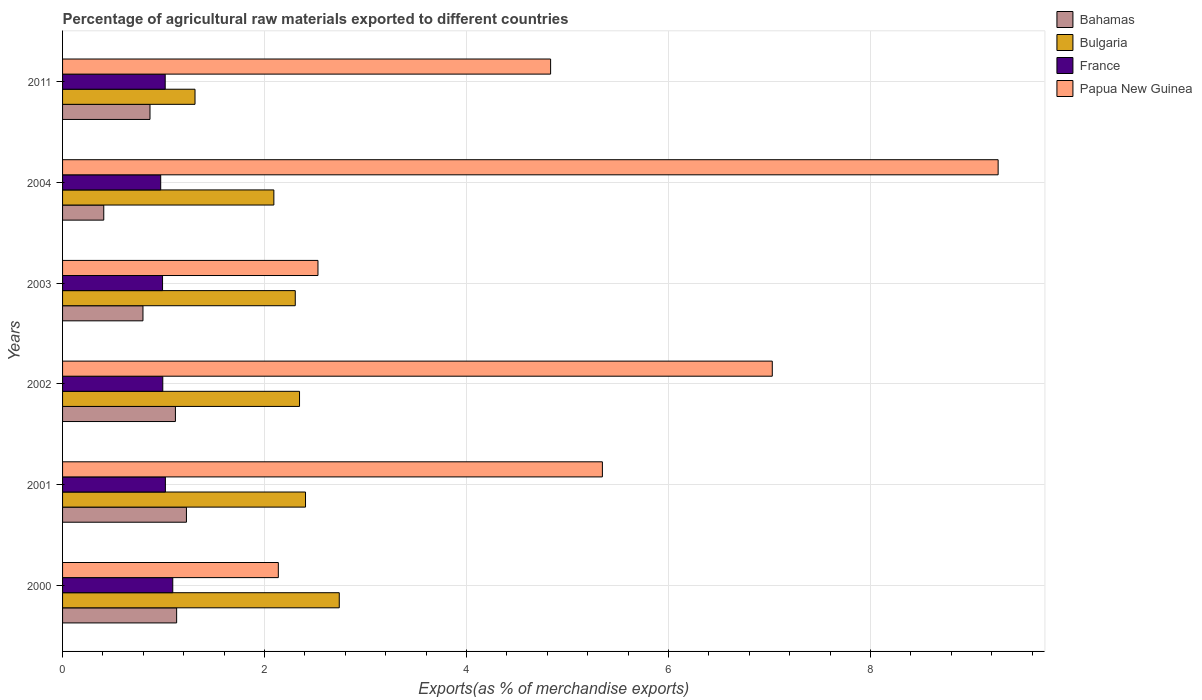How many different coloured bars are there?
Offer a terse response. 4. How many groups of bars are there?
Ensure brevity in your answer.  6. How many bars are there on the 3rd tick from the top?
Provide a succinct answer. 4. What is the label of the 5th group of bars from the top?
Offer a very short reply. 2001. What is the percentage of exports to different countries in France in 2011?
Offer a very short reply. 1.02. Across all years, what is the maximum percentage of exports to different countries in Bulgaria?
Provide a succinct answer. 2.74. Across all years, what is the minimum percentage of exports to different countries in France?
Your response must be concise. 0.97. What is the total percentage of exports to different countries in Papua New Guinea in the graph?
Ensure brevity in your answer.  31.13. What is the difference between the percentage of exports to different countries in France in 2001 and that in 2002?
Make the answer very short. 0.03. What is the difference between the percentage of exports to different countries in Bulgaria in 2001 and the percentage of exports to different countries in Papua New Guinea in 2002?
Give a very brief answer. -4.62. What is the average percentage of exports to different countries in Bahamas per year?
Keep it short and to the point. 0.92. In the year 2004, what is the difference between the percentage of exports to different countries in France and percentage of exports to different countries in Papua New Guinea?
Your response must be concise. -8.29. What is the ratio of the percentage of exports to different countries in Bulgaria in 2001 to that in 2011?
Give a very brief answer. 1.83. What is the difference between the highest and the second highest percentage of exports to different countries in France?
Give a very brief answer. 0.07. What is the difference between the highest and the lowest percentage of exports to different countries in France?
Give a very brief answer. 0.12. Is the sum of the percentage of exports to different countries in Bahamas in 2003 and 2004 greater than the maximum percentage of exports to different countries in Papua New Guinea across all years?
Provide a short and direct response. No. What does the 4th bar from the top in 2000 represents?
Your answer should be very brief. Bahamas. Is it the case that in every year, the sum of the percentage of exports to different countries in France and percentage of exports to different countries in Bulgaria is greater than the percentage of exports to different countries in Papua New Guinea?
Offer a terse response. No. How many bars are there?
Offer a very short reply. 24. What is the difference between two consecutive major ticks on the X-axis?
Your response must be concise. 2. Are the values on the major ticks of X-axis written in scientific E-notation?
Your answer should be very brief. No. Does the graph contain any zero values?
Offer a terse response. No. Does the graph contain grids?
Your answer should be compact. Yes. Where does the legend appear in the graph?
Your answer should be very brief. Top right. What is the title of the graph?
Make the answer very short. Percentage of agricultural raw materials exported to different countries. What is the label or title of the X-axis?
Make the answer very short. Exports(as % of merchandise exports). What is the Exports(as % of merchandise exports) of Bahamas in 2000?
Your answer should be compact. 1.13. What is the Exports(as % of merchandise exports) of Bulgaria in 2000?
Your answer should be compact. 2.74. What is the Exports(as % of merchandise exports) in France in 2000?
Your answer should be compact. 1.09. What is the Exports(as % of merchandise exports) in Papua New Guinea in 2000?
Make the answer very short. 2.14. What is the Exports(as % of merchandise exports) of Bahamas in 2001?
Offer a terse response. 1.23. What is the Exports(as % of merchandise exports) of Bulgaria in 2001?
Provide a succinct answer. 2.41. What is the Exports(as % of merchandise exports) of France in 2001?
Your answer should be very brief. 1.02. What is the Exports(as % of merchandise exports) in Papua New Guinea in 2001?
Your answer should be compact. 5.34. What is the Exports(as % of merchandise exports) in Bahamas in 2002?
Keep it short and to the point. 1.12. What is the Exports(as % of merchandise exports) of Bulgaria in 2002?
Your answer should be very brief. 2.35. What is the Exports(as % of merchandise exports) in France in 2002?
Give a very brief answer. 0.99. What is the Exports(as % of merchandise exports) of Papua New Guinea in 2002?
Give a very brief answer. 7.03. What is the Exports(as % of merchandise exports) in Bahamas in 2003?
Ensure brevity in your answer.  0.8. What is the Exports(as % of merchandise exports) of Bulgaria in 2003?
Keep it short and to the point. 2.3. What is the Exports(as % of merchandise exports) in France in 2003?
Make the answer very short. 0.99. What is the Exports(as % of merchandise exports) of Papua New Guinea in 2003?
Ensure brevity in your answer.  2.53. What is the Exports(as % of merchandise exports) of Bahamas in 2004?
Make the answer very short. 0.41. What is the Exports(as % of merchandise exports) of Bulgaria in 2004?
Offer a very short reply. 2.09. What is the Exports(as % of merchandise exports) of France in 2004?
Your response must be concise. 0.97. What is the Exports(as % of merchandise exports) in Papua New Guinea in 2004?
Your answer should be compact. 9.26. What is the Exports(as % of merchandise exports) of Bahamas in 2011?
Your response must be concise. 0.87. What is the Exports(as % of merchandise exports) of Bulgaria in 2011?
Give a very brief answer. 1.31. What is the Exports(as % of merchandise exports) in France in 2011?
Offer a very short reply. 1.02. What is the Exports(as % of merchandise exports) of Papua New Guinea in 2011?
Offer a very short reply. 4.83. Across all years, what is the maximum Exports(as % of merchandise exports) in Bahamas?
Keep it short and to the point. 1.23. Across all years, what is the maximum Exports(as % of merchandise exports) in Bulgaria?
Make the answer very short. 2.74. Across all years, what is the maximum Exports(as % of merchandise exports) in France?
Provide a short and direct response. 1.09. Across all years, what is the maximum Exports(as % of merchandise exports) in Papua New Guinea?
Your answer should be compact. 9.26. Across all years, what is the minimum Exports(as % of merchandise exports) in Bahamas?
Provide a succinct answer. 0.41. Across all years, what is the minimum Exports(as % of merchandise exports) in Bulgaria?
Keep it short and to the point. 1.31. Across all years, what is the minimum Exports(as % of merchandise exports) in France?
Ensure brevity in your answer.  0.97. Across all years, what is the minimum Exports(as % of merchandise exports) of Papua New Guinea?
Offer a very short reply. 2.14. What is the total Exports(as % of merchandise exports) of Bahamas in the graph?
Your answer should be compact. 5.54. What is the total Exports(as % of merchandise exports) in Bulgaria in the graph?
Make the answer very short. 13.2. What is the total Exports(as % of merchandise exports) of France in the graph?
Make the answer very short. 6.08. What is the total Exports(as % of merchandise exports) in Papua New Guinea in the graph?
Keep it short and to the point. 31.13. What is the difference between the Exports(as % of merchandise exports) of Bahamas in 2000 and that in 2001?
Keep it short and to the point. -0.1. What is the difference between the Exports(as % of merchandise exports) in Bulgaria in 2000 and that in 2001?
Offer a very short reply. 0.33. What is the difference between the Exports(as % of merchandise exports) of France in 2000 and that in 2001?
Keep it short and to the point. 0.07. What is the difference between the Exports(as % of merchandise exports) in Papua New Guinea in 2000 and that in 2001?
Your response must be concise. -3.21. What is the difference between the Exports(as % of merchandise exports) in Bahamas in 2000 and that in 2002?
Ensure brevity in your answer.  0.01. What is the difference between the Exports(as % of merchandise exports) of Bulgaria in 2000 and that in 2002?
Make the answer very short. 0.39. What is the difference between the Exports(as % of merchandise exports) in France in 2000 and that in 2002?
Offer a terse response. 0.1. What is the difference between the Exports(as % of merchandise exports) in Papua New Guinea in 2000 and that in 2002?
Keep it short and to the point. -4.89. What is the difference between the Exports(as % of merchandise exports) in Bulgaria in 2000 and that in 2003?
Keep it short and to the point. 0.44. What is the difference between the Exports(as % of merchandise exports) of France in 2000 and that in 2003?
Provide a succinct answer. 0.1. What is the difference between the Exports(as % of merchandise exports) in Papua New Guinea in 2000 and that in 2003?
Your response must be concise. -0.39. What is the difference between the Exports(as % of merchandise exports) in Bahamas in 2000 and that in 2004?
Keep it short and to the point. 0.72. What is the difference between the Exports(as % of merchandise exports) of Bulgaria in 2000 and that in 2004?
Offer a very short reply. 0.65. What is the difference between the Exports(as % of merchandise exports) in France in 2000 and that in 2004?
Offer a very short reply. 0.12. What is the difference between the Exports(as % of merchandise exports) of Papua New Guinea in 2000 and that in 2004?
Your answer should be very brief. -7.13. What is the difference between the Exports(as % of merchandise exports) in Bahamas in 2000 and that in 2011?
Ensure brevity in your answer.  0.26. What is the difference between the Exports(as % of merchandise exports) of Bulgaria in 2000 and that in 2011?
Offer a terse response. 1.43. What is the difference between the Exports(as % of merchandise exports) of France in 2000 and that in 2011?
Offer a very short reply. 0.07. What is the difference between the Exports(as % of merchandise exports) of Papua New Guinea in 2000 and that in 2011?
Your response must be concise. -2.7. What is the difference between the Exports(as % of merchandise exports) in Bahamas in 2001 and that in 2002?
Your answer should be very brief. 0.11. What is the difference between the Exports(as % of merchandise exports) in Bulgaria in 2001 and that in 2002?
Your answer should be very brief. 0.06. What is the difference between the Exports(as % of merchandise exports) in France in 2001 and that in 2002?
Your response must be concise. 0.03. What is the difference between the Exports(as % of merchandise exports) in Papua New Guinea in 2001 and that in 2002?
Your answer should be very brief. -1.68. What is the difference between the Exports(as % of merchandise exports) of Bahamas in 2001 and that in 2003?
Give a very brief answer. 0.43. What is the difference between the Exports(as % of merchandise exports) in Bulgaria in 2001 and that in 2003?
Provide a succinct answer. 0.1. What is the difference between the Exports(as % of merchandise exports) in France in 2001 and that in 2003?
Ensure brevity in your answer.  0.03. What is the difference between the Exports(as % of merchandise exports) in Papua New Guinea in 2001 and that in 2003?
Your answer should be very brief. 2.82. What is the difference between the Exports(as % of merchandise exports) in Bahamas in 2001 and that in 2004?
Give a very brief answer. 0.82. What is the difference between the Exports(as % of merchandise exports) in Bulgaria in 2001 and that in 2004?
Your answer should be compact. 0.31. What is the difference between the Exports(as % of merchandise exports) in France in 2001 and that in 2004?
Your response must be concise. 0.05. What is the difference between the Exports(as % of merchandise exports) in Papua New Guinea in 2001 and that in 2004?
Your answer should be very brief. -3.92. What is the difference between the Exports(as % of merchandise exports) in Bahamas in 2001 and that in 2011?
Offer a terse response. 0.36. What is the difference between the Exports(as % of merchandise exports) of Bulgaria in 2001 and that in 2011?
Your response must be concise. 1.09. What is the difference between the Exports(as % of merchandise exports) of France in 2001 and that in 2011?
Your response must be concise. 0. What is the difference between the Exports(as % of merchandise exports) of Papua New Guinea in 2001 and that in 2011?
Make the answer very short. 0.51. What is the difference between the Exports(as % of merchandise exports) in Bahamas in 2002 and that in 2003?
Ensure brevity in your answer.  0.32. What is the difference between the Exports(as % of merchandise exports) of Bulgaria in 2002 and that in 2003?
Ensure brevity in your answer.  0.04. What is the difference between the Exports(as % of merchandise exports) of France in 2002 and that in 2003?
Provide a short and direct response. 0. What is the difference between the Exports(as % of merchandise exports) in Papua New Guinea in 2002 and that in 2003?
Ensure brevity in your answer.  4.5. What is the difference between the Exports(as % of merchandise exports) of Bahamas in 2002 and that in 2004?
Offer a terse response. 0.71. What is the difference between the Exports(as % of merchandise exports) in Bulgaria in 2002 and that in 2004?
Offer a terse response. 0.25. What is the difference between the Exports(as % of merchandise exports) of France in 2002 and that in 2004?
Provide a succinct answer. 0.02. What is the difference between the Exports(as % of merchandise exports) in Papua New Guinea in 2002 and that in 2004?
Ensure brevity in your answer.  -2.24. What is the difference between the Exports(as % of merchandise exports) in Bahamas in 2002 and that in 2011?
Your answer should be compact. 0.25. What is the difference between the Exports(as % of merchandise exports) of Bulgaria in 2002 and that in 2011?
Give a very brief answer. 1.03. What is the difference between the Exports(as % of merchandise exports) of France in 2002 and that in 2011?
Offer a terse response. -0.02. What is the difference between the Exports(as % of merchandise exports) in Papua New Guinea in 2002 and that in 2011?
Provide a short and direct response. 2.19. What is the difference between the Exports(as % of merchandise exports) of Bahamas in 2003 and that in 2004?
Offer a very short reply. 0.39. What is the difference between the Exports(as % of merchandise exports) in Bulgaria in 2003 and that in 2004?
Ensure brevity in your answer.  0.21. What is the difference between the Exports(as % of merchandise exports) in France in 2003 and that in 2004?
Give a very brief answer. 0.02. What is the difference between the Exports(as % of merchandise exports) of Papua New Guinea in 2003 and that in 2004?
Keep it short and to the point. -6.73. What is the difference between the Exports(as % of merchandise exports) in Bahamas in 2003 and that in 2011?
Provide a succinct answer. -0.07. What is the difference between the Exports(as % of merchandise exports) of France in 2003 and that in 2011?
Your response must be concise. -0.03. What is the difference between the Exports(as % of merchandise exports) in Papua New Guinea in 2003 and that in 2011?
Offer a terse response. -2.3. What is the difference between the Exports(as % of merchandise exports) of Bahamas in 2004 and that in 2011?
Give a very brief answer. -0.46. What is the difference between the Exports(as % of merchandise exports) in Bulgaria in 2004 and that in 2011?
Your answer should be very brief. 0.78. What is the difference between the Exports(as % of merchandise exports) in France in 2004 and that in 2011?
Make the answer very short. -0.04. What is the difference between the Exports(as % of merchandise exports) of Papua New Guinea in 2004 and that in 2011?
Provide a short and direct response. 4.43. What is the difference between the Exports(as % of merchandise exports) of Bahamas in 2000 and the Exports(as % of merchandise exports) of Bulgaria in 2001?
Provide a short and direct response. -1.28. What is the difference between the Exports(as % of merchandise exports) in Bahamas in 2000 and the Exports(as % of merchandise exports) in France in 2001?
Offer a very short reply. 0.11. What is the difference between the Exports(as % of merchandise exports) of Bahamas in 2000 and the Exports(as % of merchandise exports) of Papua New Guinea in 2001?
Keep it short and to the point. -4.22. What is the difference between the Exports(as % of merchandise exports) of Bulgaria in 2000 and the Exports(as % of merchandise exports) of France in 2001?
Your answer should be compact. 1.72. What is the difference between the Exports(as % of merchandise exports) of Bulgaria in 2000 and the Exports(as % of merchandise exports) of Papua New Guinea in 2001?
Your answer should be very brief. -2.61. What is the difference between the Exports(as % of merchandise exports) in France in 2000 and the Exports(as % of merchandise exports) in Papua New Guinea in 2001?
Provide a short and direct response. -4.25. What is the difference between the Exports(as % of merchandise exports) in Bahamas in 2000 and the Exports(as % of merchandise exports) in Bulgaria in 2002?
Provide a succinct answer. -1.22. What is the difference between the Exports(as % of merchandise exports) of Bahamas in 2000 and the Exports(as % of merchandise exports) of France in 2002?
Provide a short and direct response. 0.14. What is the difference between the Exports(as % of merchandise exports) of Bahamas in 2000 and the Exports(as % of merchandise exports) of Papua New Guinea in 2002?
Ensure brevity in your answer.  -5.9. What is the difference between the Exports(as % of merchandise exports) in Bulgaria in 2000 and the Exports(as % of merchandise exports) in France in 2002?
Make the answer very short. 1.75. What is the difference between the Exports(as % of merchandise exports) in Bulgaria in 2000 and the Exports(as % of merchandise exports) in Papua New Guinea in 2002?
Offer a terse response. -4.29. What is the difference between the Exports(as % of merchandise exports) in France in 2000 and the Exports(as % of merchandise exports) in Papua New Guinea in 2002?
Ensure brevity in your answer.  -5.94. What is the difference between the Exports(as % of merchandise exports) of Bahamas in 2000 and the Exports(as % of merchandise exports) of Bulgaria in 2003?
Offer a terse response. -1.17. What is the difference between the Exports(as % of merchandise exports) in Bahamas in 2000 and the Exports(as % of merchandise exports) in France in 2003?
Ensure brevity in your answer.  0.14. What is the difference between the Exports(as % of merchandise exports) in Bahamas in 2000 and the Exports(as % of merchandise exports) in Papua New Guinea in 2003?
Keep it short and to the point. -1.4. What is the difference between the Exports(as % of merchandise exports) of Bulgaria in 2000 and the Exports(as % of merchandise exports) of France in 2003?
Your answer should be compact. 1.75. What is the difference between the Exports(as % of merchandise exports) in Bulgaria in 2000 and the Exports(as % of merchandise exports) in Papua New Guinea in 2003?
Make the answer very short. 0.21. What is the difference between the Exports(as % of merchandise exports) in France in 2000 and the Exports(as % of merchandise exports) in Papua New Guinea in 2003?
Ensure brevity in your answer.  -1.44. What is the difference between the Exports(as % of merchandise exports) in Bahamas in 2000 and the Exports(as % of merchandise exports) in Bulgaria in 2004?
Offer a very short reply. -0.96. What is the difference between the Exports(as % of merchandise exports) of Bahamas in 2000 and the Exports(as % of merchandise exports) of France in 2004?
Your response must be concise. 0.16. What is the difference between the Exports(as % of merchandise exports) of Bahamas in 2000 and the Exports(as % of merchandise exports) of Papua New Guinea in 2004?
Make the answer very short. -8.13. What is the difference between the Exports(as % of merchandise exports) in Bulgaria in 2000 and the Exports(as % of merchandise exports) in France in 2004?
Give a very brief answer. 1.77. What is the difference between the Exports(as % of merchandise exports) of Bulgaria in 2000 and the Exports(as % of merchandise exports) of Papua New Guinea in 2004?
Your answer should be very brief. -6.52. What is the difference between the Exports(as % of merchandise exports) in France in 2000 and the Exports(as % of merchandise exports) in Papua New Guinea in 2004?
Provide a short and direct response. -8.17. What is the difference between the Exports(as % of merchandise exports) of Bahamas in 2000 and the Exports(as % of merchandise exports) of Bulgaria in 2011?
Provide a succinct answer. -0.18. What is the difference between the Exports(as % of merchandise exports) in Bahamas in 2000 and the Exports(as % of merchandise exports) in France in 2011?
Offer a very short reply. 0.11. What is the difference between the Exports(as % of merchandise exports) of Bahamas in 2000 and the Exports(as % of merchandise exports) of Papua New Guinea in 2011?
Offer a terse response. -3.7. What is the difference between the Exports(as % of merchandise exports) in Bulgaria in 2000 and the Exports(as % of merchandise exports) in France in 2011?
Provide a short and direct response. 1.72. What is the difference between the Exports(as % of merchandise exports) in Bulgaria in 2000 and the Exports(as % of merchandise exports) in Papua New Guinea in 2011?
Keep it short and to the point. -2.09. What is the difference between the Exports(as % of merchandise exports) in France in 2000 and the Exports(as % of merchandise exports) in Papua New Guinea in 2011?
Your answer should be very brief. -3.74. What is the difference between the Exports(as % of merchandise exports) of Bahamas in 2001 and the Exports(as % of merchandise exports) of Bulgaria in 2002?
Make the answer very short. -1.12. What is the difference between the Exports(as % of merchandise exports) in Bahamas in 2001 and the Exports(as % of merchandise exports) in France in 2002?
Provide a succinct answer. 0.23. What is the difference between the Exports(as % of merchandise exports) of Bahamas in 2001 and the Exports(as % of merchandise exports) of Papua New Guinea in 2002?
Your response must be concise. -5.8. What is the difference between the Exports(as % of merchandise exports) of Bulgaria in 2001 and the Exports(as % of merchandise exports) of France in 2002?
Give a very brief answer. 1.41. What is the difference between the Exports(as % of merchandise exports) of Bulgaria in 2001 and the Exports(as % of merchandise exports) of Papua New Guinea in 2002?
Offer a terse response. -4.62. What is the difference between the Exports(as % of merchandise exports) of France in 2001 and the Exports(as % of merchandise exports) of Papua New Guinea in 2002?
Offer a terse response. -6.01. What is the difference between the Exports(as % of merchandise exports) in Bahamas in 2001 and the Exports(as % of merchandise exports) in Bulgaria in 2003?
Make the answer very short. -1.08. What is the difference between the Exports(as % of merchandise exports) in Bahamas in 2001 and the Exports(as % of merchandise exports) in France in 2003?
Offer a very short reply. 0.24. What is the difference between the Exports(as % of merchandise exports) in Bahamas in 2001 and the Exports(as % of merchandise exports) in Papua New Guinea in 2003?
Your response must be concise. -1.3. What is the difference between the Exports(as % of merchandise exports) of Bulgaria in 2001 and the Exports(as % of merchandise exports) of France in 2003?
Offer a very short reply. 1.42. What is the difference between the Exports(as % of merchandise exports) in Bulgaria in 2001 and the Exports(as % of merchandise exports) in Papua New Guinea in 2003?
Your answer should be very brief. -0.12. What is the difference between the Exports(as % of merchandise exports) of France in 2001 and the Exports(as % of merchandise exports) of Papua New Guinea in 2003?
Offer a terse response. -1.51. What is the difference between the Exports(as % of merchandise exports) in Bahamas in 2001 and the Exports(as % of merchandise exports) in Bulgaria in 2004?
Provide a succinct answer. -0.87. What is the difference between the Exports(as % of merchandise exports) in Bahamas in 2001 and the Exports(as % of merchandise exports) in France in 2004?
Make the answer very short. 0.25. What is the difference between the Exports(as % of merchandise exports) of Bahamas in 2001 and the Exports(as % of merchandise exports) of Papua New Guinea in 2004?
Provide a succinct answer. -8.04. What is the difference between the Exports(as % of merchandise exports) in Bulgaria in 2001 and the Exports(as % of merchandise exports) in France in 2004?
Keep it short and to the point. 1.43. What is the difference between the Exports(as % of merchandise exports) of Bulgaria in 2001 and the Exports(as % of merchandise exports) of Papua New Guinea in 2004?
Keep it short and to the point. -6.86. What is the difference between the Exports(as % of merchandise exports) of France in 2001 and the Exports(as % of merchandise exports) of Papua New Guinea in 2004?
Keep it short and to the point. -8.24. What is the difference between the Exports(as % of merchandise exports) of Bahamas in 2001 and the Exports(as % of merchandise exports) of Bulgaria in 2011?
Give a very brief answer. -0.08. What is the difference between the Exports(as % of merchandise exports) of Bahamas in 2001 and the Exports(as % of merchandise exports) of France in 2011?
Your answer should be compact. 0.21. What is the difference between the Exports(as % of merchandise exports) in Bahamas in 2001 and the Exports(as % of merchandise exports) in Papua New Guinea in 2011?
Ensure brevity in your answer.  -3.61. What is the difference between the Exports(as % of merchandise exports) of Bulgaria in 2001 and the Exports(as % of merchandise exports) of France in 2011?
Offer a very short reply. 1.39. What is the difference between the Exports(as % of merchandise exports) of Bulgaria in 2001 and the Exports(as % of merchandise exports) of Papua New Guinea in 2011?
Keep it short and to the point. -2.43. What is the difference between the Exports(as % of merchandise exports) in France in 2001 and the Exports(as % of merchandise exports) in Papua New Guinea in 2011?
Your answer should be compact. -3.81. What is the difference between the Exports(as % of merchandise exports) in Bahamas in 2002 and the Exports(as % of merchandise exports) in Bulgaria in 2003?
Offer a very short reply. -1.19. What is the difference between the Exports(as % of merchandise exports) in Bahamas in 2002 and the Exports(as % of merchandise exports) in France in 2003?
Provide a short and direct response. 0.13. What is the difference between the Exports(as % of merchandise exports) of Bahamas in 2002 and the Exports(as % of merchandise exports) of Papua New Guinea in 2003?
Keep it short and to the point. -1.41. What is the difference between the Exports(as % of merchandise exports) in Bulgaria in 2002 and the Exports(as % of merchandise exports) in France in 2003?
Keep it short and to the point. 1.36. What is the difference between the Exports(as % of merchandise exports) of Bulgaria in 2002 and the Exports(as % of merchandise exports) of Papua New Guinea in 2003?
Your answer should be very brief. -0.18. What is the difference between the Exports(as % of merchandise exports) in France in 2002 and the Exports(as % of merchandise exports) in Papua New Guinea in 2003?
Your response must be concise. -1.54. What is the difference between the Exports(as % of merchandise exports) in Bahamas in 2002 and the Exports(as % of merchandise exports) in Bulgaria in 2004?
Give a very brief answer. -0.97. What is the difference between the Exports(as % of merchandise exports) in Bahamas in 2002 and the Exports(as % of merchandise exports) in France in 2004?
Keep it short and to the point. 0.15. What is the difference between the Exports(as % of merchandise exports) of Bahamas in 2002 and the Exports(as % of merchandise exports) of Papua New Guinea in 2004?
Your answer should be compact. -8.15. What is the difference between the Exports(as % of merchandise exports) of Bulgaria in 2002 and the Exports(as % of merchandise exports) of France in 2004?
Your answer should be very brief. 1.37. What is the difference between the Exports(as % of merchandise exports) of Bulgaria in 2002 and the Exports(as % of merchandise exports) of Papua New Guinea in 2004?
Your answer should be very brief. -6.92. What is the difference between the Exports(as % of merchandise exports) of France in 2002 and the Exports(as % of merchandise exports) of Papua New Guinea in 2004?
Offer a very short reply. -8.27. What is the difference between the Exports(as % of merchandise exports) of Bahamas in 2002 and the Exports(as % of merchandise exports) of Bulgaria in 2011?
Give a very brief answer. -0.19. What is the difference between the Exports(as % of merchandise exports) of Bahamas in 2002 and the Exports(as % of merchandise exports) of France in 2011?
Offer a terse response. 0.1. What is the difference between the Exports(as % of merchandise exports) in Bahamas in 2002 and the Exports(as % of merchandise exports) in Papua New Guinea in 2011?
Offer a very short reply. -3.71. What is the difference between the Exports(as % of merchandise exports) of Bulgaria in 2002 and the Exports(as % of merchandise exports) of France in 2011?
Offer a very short reply. 1.33. What is the difference between the Exports(as % of merchandise exports) of Bulgaria in 2002 and the Exports(as % of merchandise exports) of Papua New Guinea in 2011?
Offer a very short reply. -2.49. What is the difference between the Exports(as % of merchandise exports) of France in 2002 and the Exports(as % of merchandise exports) of Papua New Guinea in 2011?
Keep it short and to the point. -3.84. What is the difference between the Exports(as % of merchandise exports) of Bahamas in 2003 and the Exports(as % of merchandise exports) of Bulgaria in 2004?
Keep it short and to the point. -1.3. What is the difference between the Exports(as % of merchandise exports) of Bahamas in 2003 and the Exports(as % of merchandise exports) of France in 2004?
Ensure brevity in your answer.  -0.18. What is the difference between the Exports(as % of merchandise exports) of Bahamas in 2003 and the Exports(as % of merchandise exports) of Papua New Guinea in 2004?
Give a very brief answer. -8.47. What is the difference between the Exports(as % of merchandise exports) of Bulgaria in 2003 and the Exports(as % of merchandise exports) of France in 2004?
Offer a very short reply. 1.33. What is the difference between the Exports(as % of merchandise exports) in Bulgaria in 2003 and the Exports(as % of merchandise exports) in Papua New Guinea in 2004?
Make the answer very short. -6.96. What is the difference between the Exports(as % of merchandise exports) in France in 2003 and the Exports(as % of merchandise exports) in Papua New Guinea in 2004?
Ensure brevity in your answer.  -8.27. What is the difference between the Exports(as % of merchandise exports) in Bahamas in 2003 and the Exports(as % of merchandise exports) in Bulgaria in 2011?
Make the answer very short. -0.52. What is the difference between the Exports(as % of merchandise exports) in Bahamas in 2003 and the Exports(as % of merchandise exports) in France in 2011?
Give a very brief answer. -0.22. What is the difference between the Exports(as % of merchandise exports) in Bahamas in 2003 and the Exports(as % of merchandise exports) in Papua New Guinea in 2011?
Give a very brief answer. -4.04. What is the difference between the Exports(as % of merchandise exports) in Bulgaria in 2003 and the Exports(as % of merchandise exports) in France in 2011?
Provide a short and direct response. 1.29. What is the difference between the Exports(as % of merchandise exports) in Bulgaria in 2003 and the Exports(as % of merchandise exports) in Papua New Guinea in 2011?
Make the answer very short. -2.53. What is the difference between the Exports(as % of merchandise exports) in France in 2003 and the Exports(as % of merchandise exports) in Papua New Guinea in 2011?
Make the answer very short. -3.84. What is the difference between the Exports(as % of merchandise exports) of Bahamas in 2004 and the Exports(as % of merchandise exports) of Bulgaria in 2011?
Make the answer very short. -0.9. What is the difference between the Exports(as % of merchandise exports) in Bahamas in 2004 and the Exports(as % of merchandise exports) in France in 2011?
Your answer should be very brief. -0.61. What is the difference between the Exports(as % of merchandise exports) of Bahamas in 2004 and the Exports(as % of merchandise exports) of Papua New Guinea in 2011?
Make the answer very short. -4.42. What is the difference between the Exports(as % of merchandise exports) in Bulgaria in 2004 and the Exports(as % of merchandise exports) in France in 2011?
Ensure brevity in your answer.  1.08. What is the difference between the Exports(as % of merchandise exports) of Bulgaria in 2004 and the Exports(as % of merchandise exports) of Papua New Guinea in 2011?
Provide a short and direct response. -2.74. What is the difference between the Exports(as % of merchandise exports) of France in 2004 and the Exports(as % of merchandise exports) of Papua New Guinea in 2011?
Keep it short and to the point. -3.86. What is the average Exports(as % of merchandise exports) in Bahamas per year?
Your answer should be very brief. 0.92. What is the average Exports(as % of merchandise exports) in Bulgaria per year?
Your answer should be compact. 2.2. What is the average Exports(as % of merchandise exports) of France per year?
Provide a short and direct response. 1.01. What is the average Exports(as % of merchandise exports) in Papua New Guinea per year?
Offer a very short reply. 5.19. In the year 2000, what is the difference between the Exports(as % of merchandise exports) in Bahamas and Exports(as % of merchandise exports) in Bulgaria?
Offer a very short reply. -1.61. In the year 2000, what is the difference between the Exports(as % of merchandise exports) in Bahamas and Exports(as % of merchandise exports) in France?
Your response must be concise. 0.04. In the year 2000, what is the difference between the Exports(as % of merchandise exports) in Bahamas and Exports(as % of merchandise exports) in Papua New Guinea?
Offer a terse response. -1.01. In the year 2000, what is the difference between the Exports(as % of merchandise exports) in Bulgaria and Exports(as % of merchandise exports) in France?
Your answer should be compact. 1.65. In the year 2000, what is the difference between the Exports(as % of merchandise exports) in Bulgaria and Exports(as % of merchandise exports) in Papua New Guinea?
Give a very brief answer. 0.6. In the year 2000, what is the difference between the Exports(as % of merchandise exports) in France and Exports(as % of merchandise exports) in Papua New Guinea?
Ensure brevity in your answer.  -1.05. In the year 2001, what is the difference between the Exports(as % of merchandise exports) in Bahamas and Exports(as % of merchandise exports) in Bulgaria?
Keep it short and to the point. -1.18. In the year 2001, what is the difference between the Exports(as % of merchandise exports) of Bahamas and Exports(as % of merchandise exports) of France?
Offer a terse response. 0.21. In the year 2001, what is the difference between the Exports(as % of merchandise exports) of Bahamas and Exports(as % of merchandise exports) of Papua New Guinea?
Offer a very short reply. -4.12. In the year 2001, what is the difference between the Exports(as % of merchandise exports) in Bulgaria and Exports(as % of merchandise exports) in France?
Provide a short and direct response. 1.39. In the year 2001, what is the difference between the Exports(as % of merchandise exports) of Bulgaria and Exports(as % of merchandise exports) of Papua New Guinea?
Offer a very short reply. -2.94. In the year 2001, what is the difference between the Exports(as % of merchandise exports) of France and Exports(as % of merchandise exports) of Papua New Guinea?
Make the answer very short. -4.33. In the year 2002, what is the difference between the Exports(as % of merchandise exports) in Bahamas and Exports(as % of merchandise exports) in Bulgaria?
Offer a terse response. -1.23. In the year 2002, what is the difference between the Exports(as % of merchandise exports) in Bahamas and Exports(as % of merchandise exports) in France?
Provide a short and direct response. 0.13. In the year 2002, what is the difference between the Exports(as % of merchandise exports) of Bahamas and Exports(as % of merchandise exports) of Papua New Guinea?
Offer a terse response. -5.91. In the year 2002, what is the difference between the Exports(as % of merchandise exports) of Bulgaria and Exports(as % of merchandise exports) of France?
Give a very brief answer. 1.35. In the year 2002, what is the difference between the Exports(as % of merchandise exports) of Bulgaria and Exports(as % of merchandise exports) of Papua New Guinea?
Provide a succinct answer. -4.68. In the year 2002, what is the difference between the Exports(as % of merchandise exports) in France and Exports(as % of merchandise exports) in Papua New Guinea?
Offer a terse response. -6.03. In the year 2003, what is the difference between the Exports(as % of merchandise exports) in Bahamas and Exports(as % of merchandise exports) in Bulgaria?
Provide a short and direct response. -1.51. In the year 2003, what is the difference between the Exports(as % of merchandise exports) in Bahamas and Exports(as % of merchandise exports) in France?
Offer a very short reply. -0.19. In the year 2003, what is the difference between the Exports(as % of merchandise exports) of Bahamas and Exports(as % of merchandise exports) of Papua New Guinea?
Your answer should be very brief. -1.73. In the year 2003, what is the difference between the Exports(as % of merchandise exports) of Bulgaria and Exports(as % of merchandise exports) of France?
Ensure brevity in your answer.  1.31. In the year 2003, what is the difference between the Exports(as % of merchandise exports) in Bulgaria and Exports(as % of merchandise exports) in Papua New Guinea?
Your answer should be compact. -0.22. In the year 2003, what is the difference between the Exports(as % of merchandise exports) in France and Exports(as % of merchandise exports) in Papua New Guinea?
Your answer should be very brief. -1.54. In the year 2004, what is the difference between the Exports(as % of merchandise exports) in Bahamas and Exports(as % of merchandise exports) in Bulgaria?
Offer a terse response. -1.68. In the year 2004, what is the difference between the Exports(as % of merchandise exports) in Bahamas and Exports(as % of merchandise exports) in France?
Ensure brevity in your answer.  -0.56. In the year 2004, what is the difference between the Exports(as % of merchandise exports) in Bahamas and Exports(as % of merchandise exports) in Papua New Guinea?
Your answer should be very brief. -8.86. In the year 2004, what is the difference between the Exports(as % of merchandise exports) in Bulgaria and Exports(as % of merchandise exports) in France?
Give a very brief answer. 1.12. In the year 2004, what is the difference between the Exports(as % of merchandise exports) of Bulgaria and Exports(as % of merchandise exports) of Papua New Guinea?
Offer a terse response. -7.17. In the year 2004, what is the difference between the Exports(as % of merchandise exports) in France and Exports(as % of merchandise exports) in Papua New Guinea?
Offer a very short reply. -8.29. In the year 2011, what is the difference between the Exports(as % of merchandise exports) of Bahamas and Exports(as % of merchandise exports) of Bulgaria?
Make the answer very short. -0.45. In the year 2011, what is the difference between the Exports(as % of merchandise exports) in Bahamas and Exports(as % of merchandise exports) in France?
Provide a succinct answer. -0.15. In the year 2011, what is the difference between the Exports(as % of merchandise exports) of Bahamas and Exports(as % of merchandise exports) of Papua New Guinea?
Your response must be concise. -3.97. In the year 2011, what is the difference between the Exports(as % of merchandise exports) of Bulgaria and Exports(as % of merchandise exports) of France?
Make the answer very short. 0.3. In the year 2011, what is the difference between the Exports(as % of merchandise exports) in Bulgaria and Exports(as % of merchandise exports) in Papua New Guinea?
Make the answer very short. -3.52. In the year 2011, what is the difference between the Exports(as % of merchandise exports) in France and Exports(as % of merchandise exports) in Papua New Guinea?
Make the answer very short. -3.82. What is the ratio of the Exports(as % of merchandise exports) in Bahamas in 2000 to that in 2001?
Give a very brief answer. 0.92. What is the ratio of the Exports(as % of merchandise exports) of Bulgaria in 2000 to that in 2001?
Give a very brief answer. 1.14. What is the ratio of the Exports(as % of merchandise exports) of France in 2000 to that in 2001?
Your answer should be compact. 1.07. What is the ratio of the Exports(as % of merchandise exports) of Papua New Guinea in 2000 to that in 2001?
Offer a very short reply. 0.4. What is the ratio of the Exports(as % of merchandise exports) in Bahamas in 2000 to that in 2002?
Keep it short and to the point. 1.01. What is the ratio of the Exports(as % of merchandise exports) in Bulgaria in 2000 to that in 2002?
Offer a very short reply. 1.17. What is the ratio of the Exports(as % of merchandise exports) of France in 2000 to that in 2002?
Provide a succinct answer. 1.1. What is the ratio of the Exports(as % of merchandise exports) of Papua New Guinea in 2000 to that in 2002?
Offer a very short reply. 0.3. What is the ratio of the Exports(as % of merchandise exports) in Bahamas in 2000 to that in 2003?
Offer a very short reply. 1.42. What is the ratio of the Exports(as % of merchandise exports) in Bulgaria in 2000 to that in 2003?
Your answer should be compact. 1.19. What is the ratio of the Exports(as % of merchandise exports) in France in 2000 to that in 2003?
Offer a very short reply. 1.1. What is the ratio of the Exports(as % of merchandise exports) in Papua New Guinea in 2000 to that in 2003?
Make the answer very short. 0.84. What is the ratio of the Exports(as % of merchandise exports) of Bahamas in 2000 to that in 2004?
Keep it short and to the point. 2.77. What is the ratio of the Exports(as % of merchandise exports) of Bulgaria in 2000 to that in 2004?
Give a very brief answer. 1.31. What is the ratio of the Exports(as % of merchandise exports) in France in 2000 to that in 2004?
Provide a succinct answer. 1.12. What is the ratio of the Exports(as % of merchandise exports) of Papua New Guinea in 2000 to that in 2004?
Make the answer very short. 0.23. What is the ratio of the Exports(as % of merchandise exports) in Bahamas in 2000 to that in 2011?
Offer a terse response. 1.3. What is the ratio of the Exports(as % of merchandise exports) in Bulgaria in 2000 to that in 2011?
Your answer should be compact. 2.09. What is the ratio of the Exports(as % of merchandise exports) in France in 2000 to that in 2011?
Make the answer very short. 1.07. What is the ratio of the Exports(as % of merchandise exports) of Papua New Guinea in 2000 to that in 2011?
Give a very brief answer. 0.44. What is the ratio of the Exports(as % of merchandise exports) of Bahamas in 2001 to that in 2002?
Your response must be concise. 1.1. What is the ratio of the Exports(as % of merchandise exports) of Bulgaria in 2001 to that in 2002?
Provide a short and direct response. 1.03. What is the ratio of the Exports(as % of merchandise exports) in Papua New Guinea in 2001 to that in 2002?
Give a very brief answer. 0.76. What is the ratio of the Exports(as % of merchandise exports) in Bahamas in 2001 to that in 2003?
Provide a succinct answer. 1.54. What is the ratio of the Exports(as % of merchandise exports) in Bulgaria in 2001 to that in 2003?
Your answer should be very brief. 1.04. What is the ratio of the Exports(as % of merchandise exports) in France in 2001 to that in 2003?
Make the answer very short. 1.03. What is the ratio of the Exports(as % of merchandise exports) of Papua New Guinea in 2001 to that in 2003?
Provide a short and direct response. 2.11. What is the ratio of the Exports(as % of merchandise exports) of Bahamas in 2001 to that in 2004?
Make the answer very short. 3.01. What is the ratio of the Exports(as % of merchandise exports) of Bulgaria in 2001 to that in 2004?
Offer a very short reply. 1.15. What is the ratio of the Exports(as % of merchandise exports) of France in 2001 to that in 2004?
Keep it short and to the point. 1.05. What is the ratio of the Exports(as % of merchandise exports) of Papua New Guinea in 2001 to that in 2004?
Ensure brevity in your answer.  0.58. What is the ratio of the Exports(as % of merchandise exports) of Bahamas in 2001 to that in 2011?
Provide a short and direct response. 1.42. What is the ratio of the Exports(as % of merchandise exports) of Bulgaria in 2001 to that in 2011?
Offer a very short reply. 1.83. What is the ratio of the Exports(as % of merchandise exports) of Papua New Guinea in 2001 to that in 2011?
Give a very brief answer. 1.11. What is the ratio of the Exports(as % of merchandise exports) in Bahamas in 2002 to that in 2003?
Provide a short and direct response. 1.4. What is the ratio of the Exports(as % of merchandise exports) in Bulgaria in 2002 to that in 2003?
Provide a succinct answer. 1.02. What is the ratio of the Exports(as % of merchandise exports) in France in 2002 to that in 2003?
Offer a terse response. 1. What is the ratio of the Exports(as % of merchandise exports) in Papua New Guinea in 2002 to that in 2003?
Your answer should be compact. 2.78. What is the ratio of the Exports(as % of merchandise exports) of Bahamas in 2002 to that in 2004?
Provide a succinct answer. 2.74. What is the ratio of the Exports(as % of merchandise exports) in Bulgaria in 2002 to that in 2004?
Provide a succinct answer. 1.12. What is the ratio of the Exports(as % of merchandise exports) of France in 2002 to that in 2004?
Make the answer very short. 1.02. What is the ratio of the Exports(as % of merchandise exports) in Papua New Guinea in 2002 to that in 2004?
Provide a short and direct response. 0.76. What is the ratio of the Exports(as % of merchandise exports) in Bahamas in 2002 to that in 2011?
Your response must be concise. 1.29. What is the ratio of the Exports(as % of merchandise exports) of Bulgaria in 2002 to that in 2011?
Provide a short and direct response. 1.79. What is the ratio of the Exports(as % of merchandise exports) in France in 2002 to that in 2011?
Provide a short and direct response. 0.98. What is the ratio of the Exports(as % of merchandise exports) in Papua New Guinea in 2002 to that in 2011?
Your response must be concise. 1.45. What is the ratio of the Exports(as % of merchandise exports) in Bahamas in 2003 to that in 2004?
Keep it short and to the point. 1.95. What is the ratio of the Exports(as % of merchandise exports) in Bulgaria in 2003 to that in 2004?
Keep it short and to the point. 1.1. What is the ratio of the Exports(as % of merchandise exports) of France in 2003 to that in 2004?
Provide a succinct answer. 1.02. What is the ratio of the Exports(as % of merchandise exports) in Papua New Guinea in 2003 to that in 2004?
Ensure brevity in your answer.  0.27. What is the ratio of the Exports(as % of merchandise exports) in Bahamas in 2003 to that in 2011?
Keep it short and to the point. 0.92. What is the ratio of the Exports(as % of merchandise exports) of Bulgaria in 2003 to that in 2011?
Provide a short and direct response. 1.76. What is the ratio of the Exports(as % of merchandise exports) in France in 2003 to that in 2011?
Your answer should be very brief. 0.97. What is the ratio of the Exports(as % of merchandise exports) in Papua New Guinea in 2003 to that in 2011?
Ensure brevity in your answer.  0.52. What is the ratio of the Exports(as % of merchandise exports) of Bahamas in 2004 to that in 2011?
Provide a succinct answer. 0.47. What is the ratio of the Exports(as % of merchandise exports) in Bulgaria in 2004 to that in 2011?
Provide a succinct answer. 1.6. What is the ratio of the Exports(as % of merchandise exports) in France in 2004 to that in 2011?
Your answer should be very brief. 0.96. What is the ratio of the Exports(as % of merchandise exports) of Papua New Guinea in 2004 to that in 2011?
Keep it short and to the point. 1.92. What is the difference between the highest and the second highest Exports(as % of merchandise exports) in Bahamas?
Your answer should be compact. 0.1. What is the difference between the highest and the second highest Exports(as % of merchandise exports) of Bulgaria?
Provide a succinct answer. 0.33. What is the difference between the highest and the second highest Exports(as % of merchandise exports) of France?
Your answer should be very brief. 0.07. What is the difference between the highest and the second highest Exports(as % of merchandise exports) in Papua New Guinea?
Provide a short and direct response. 2.24. What is the difference between the highest and the lowest Exports(as % of merchandise exports) of Bahamas?
Provide a succinct answer. 0.82. What is the difference between the highest and the lowest Exports(as % of merchandise exports) of Bulgaria?
Give a very brief answer. 1.43. What is the difference between the highest and the lowest Exports(as % of merchandise exports) in France?
Keep it short and to the point. 0.12. What is the difference between the highest and the lowest Exports(as % of merchandise exports) in Papua New Guinea?
Your response must be concise. 7.13. 